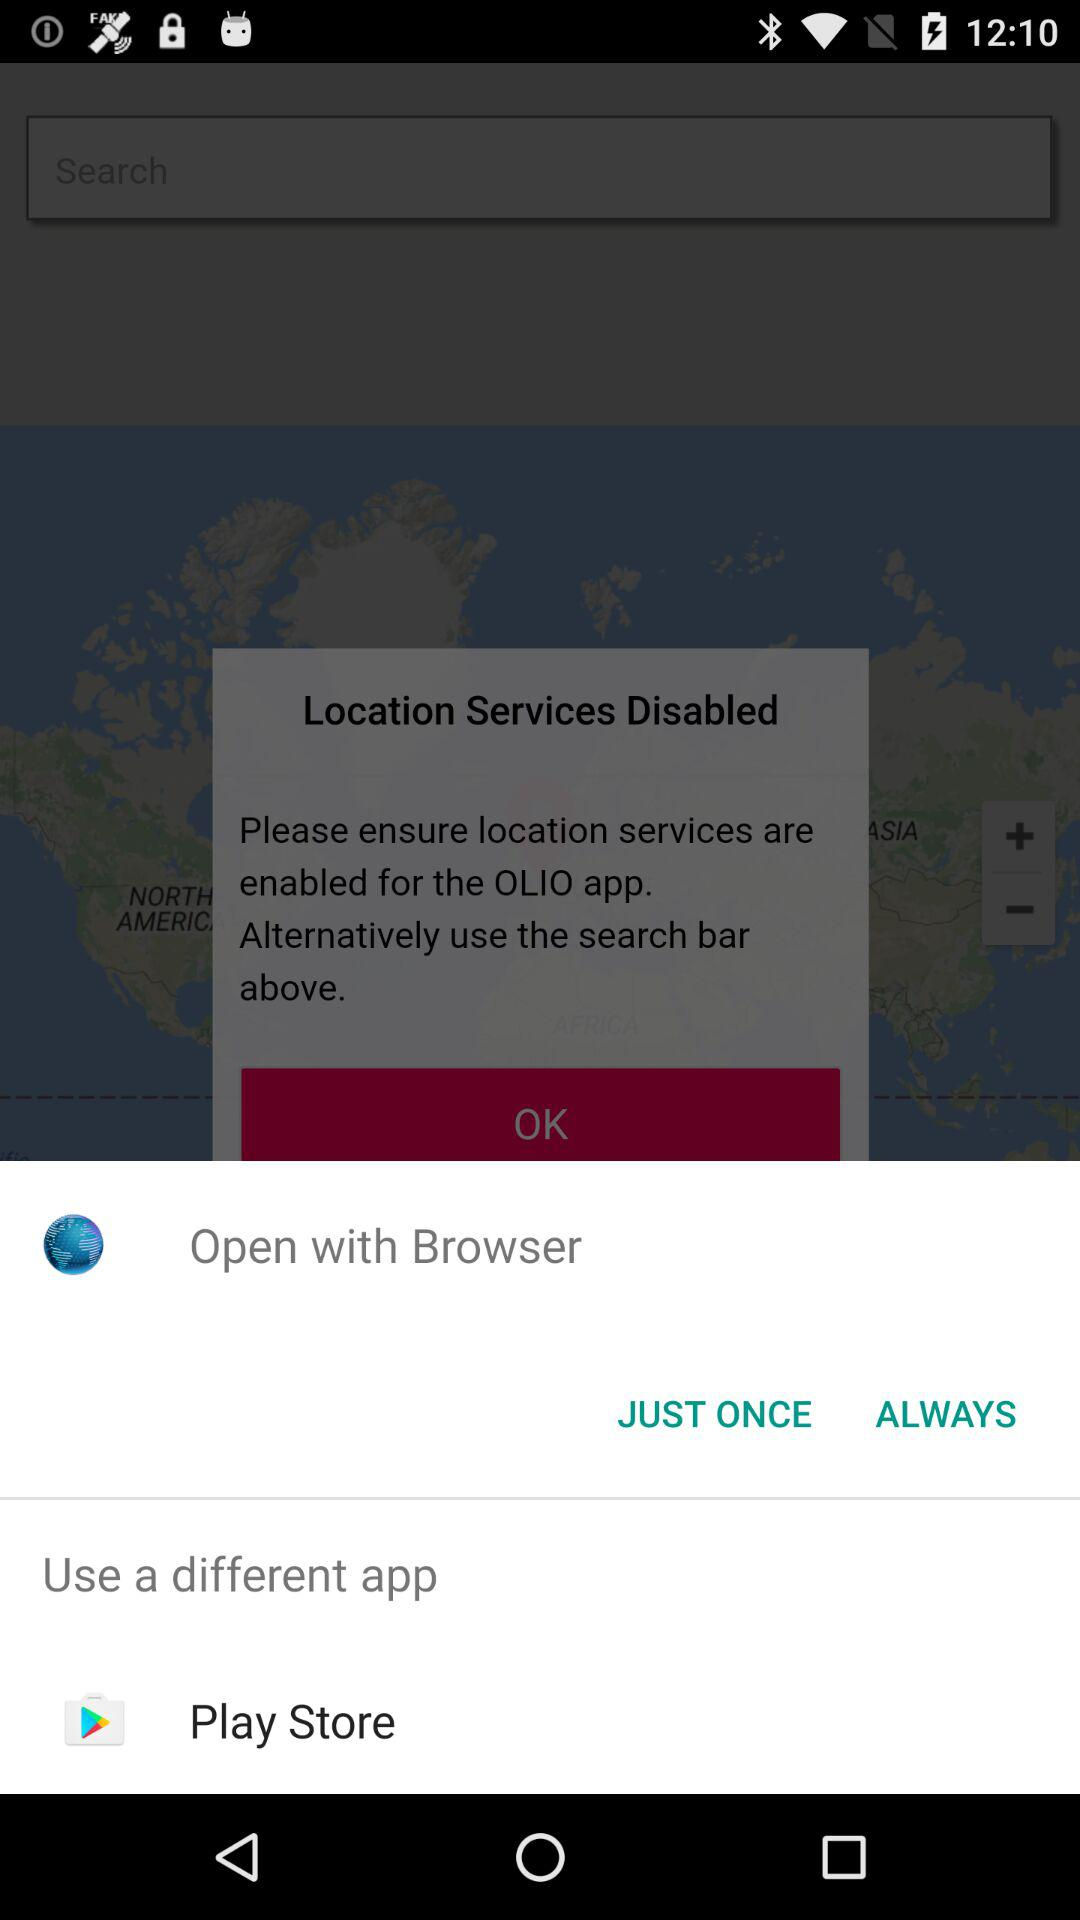Which application is selected to open the content?
When the provided information is insufficient, respond with <no answer>. <no answer> 